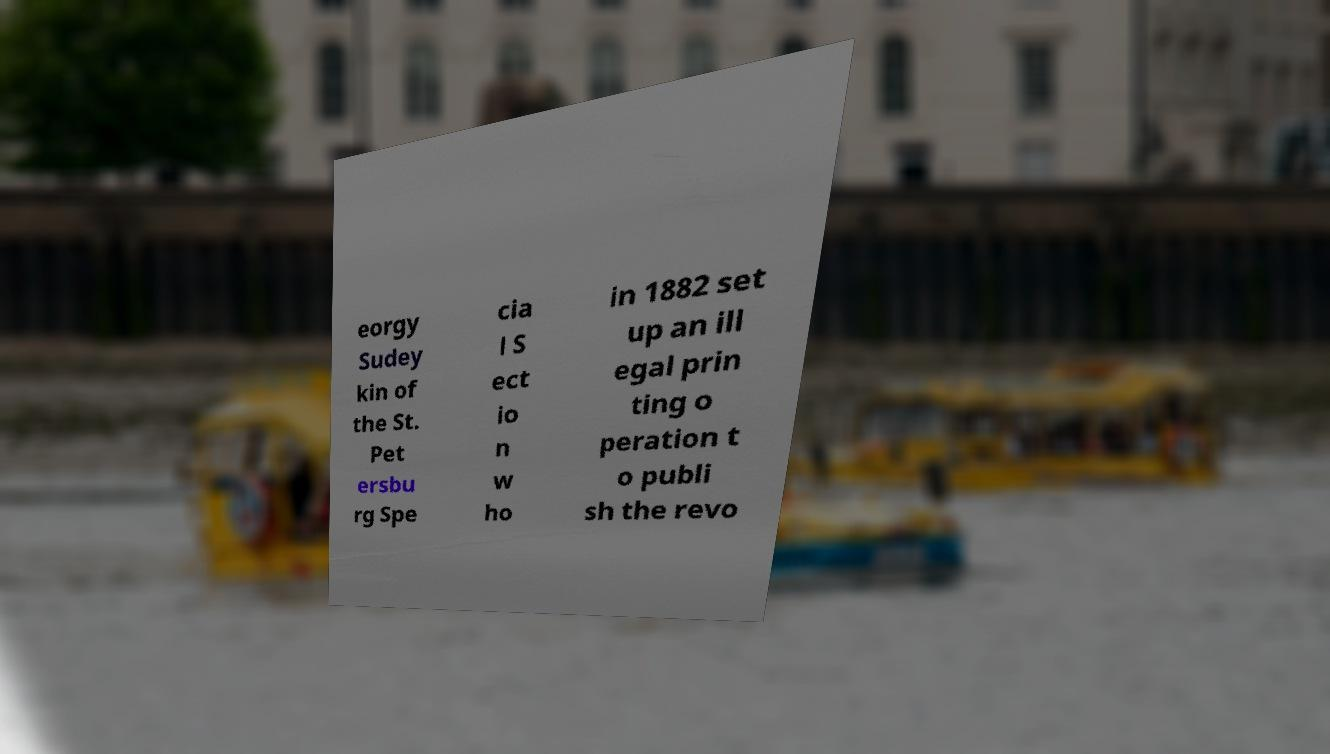Can you accurately transcribe the text from the provided image for me? eorgy Sudey kin of the St. Pet ersbu rg Spe cia l S ect io n w ho in 1882 set up an ill egal prin ting o peration t o publi sh the revo 